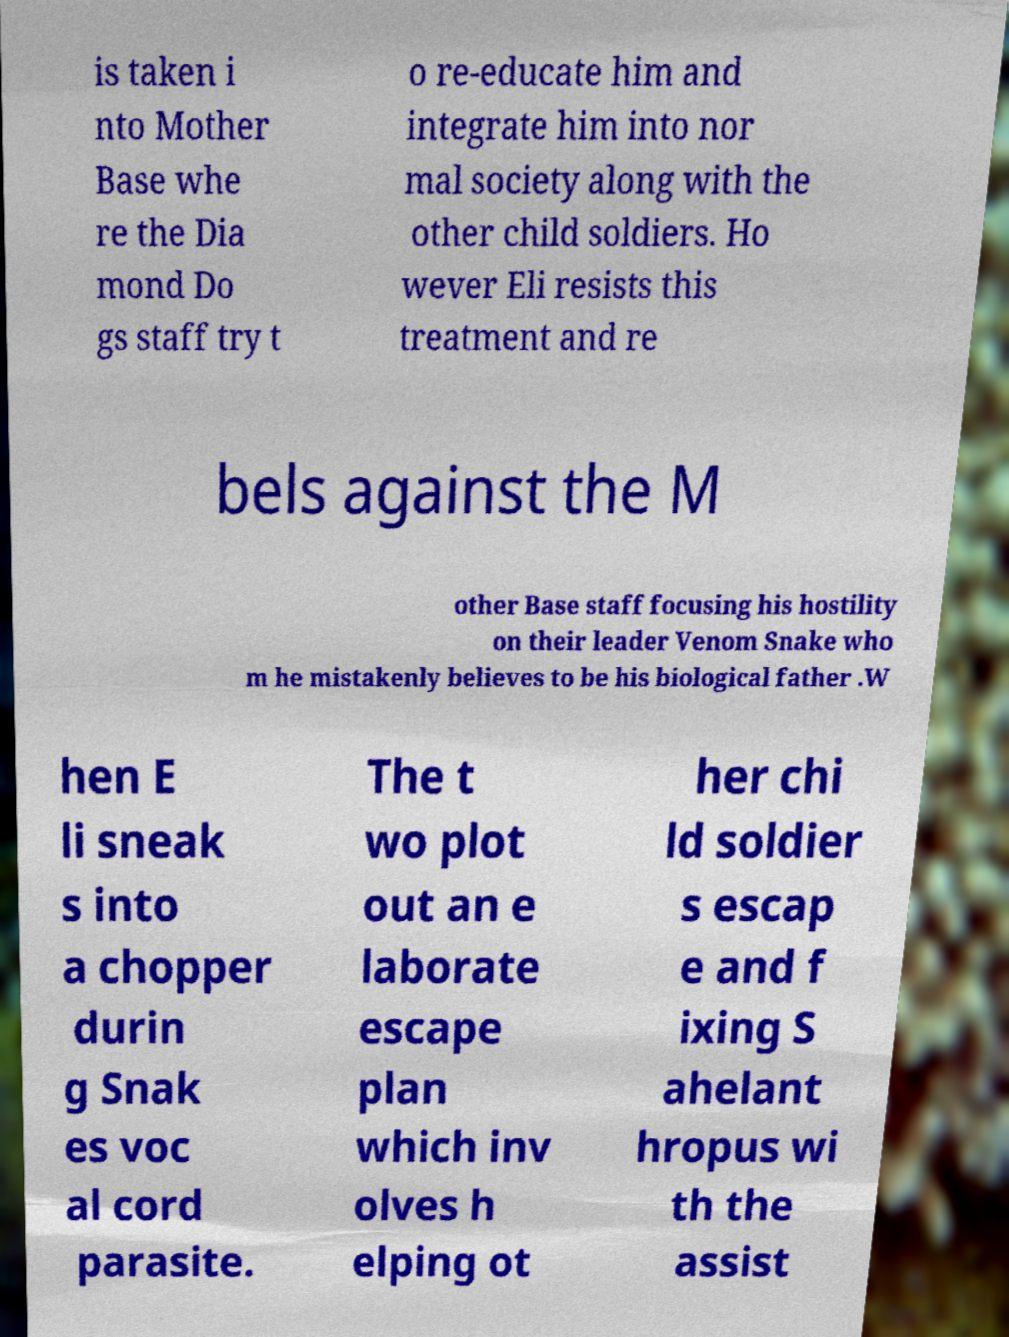For documentation purposes, I need the text within this image transcribed. Could you provide that? is taken i nto Mother Base whe re the Dia mond Do gs staff try t o re-educate him and integrate him into nor mal society along with the other child soldiers. Ho wever Eli resists this treatment and re bels against the M other Base staff focusing his hostility on their leader Venom Snake who m he mistakenly believes to be his biological father .W hen E li sneak s into a chopper durin g Snak es voc al cord parasite. The t wo plot out an e laborate escape plan which inv olves h elping ot her chi ld soldier s escap e and f ixing S ahelant hropus wi th the assist 